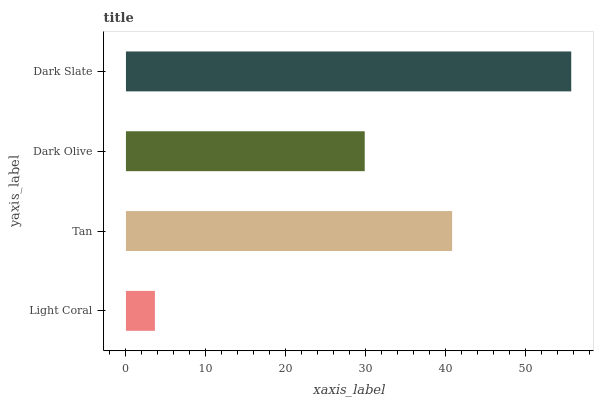Is Light Coral the minimum?
Answer yes or no. Yes. Is Dark Slate the maximum?
Answer yes or no. Yes. Is Tan the minimum?
Answer yes or no. No. Is Tan the maximum?
Answer yes or no. No. Is Tan greater than Light Coral?
Answer yes or no. Yes. Is Light Coral less than Tan?
Answer yes or no. Yes. Is Light Coral greater than Tan?
Answer yes or no. No. Is Tan less than Light Coral?
Answer yes or no. No. Is Tan the high median?
Answer yes or no. Yes. Is Dark Olive the low median?
Answer yes or no. Yes. Is Dark Slate the high median?
Answer yes or no. No. Is Light Coral the low median?
Answer yes or no. No. 